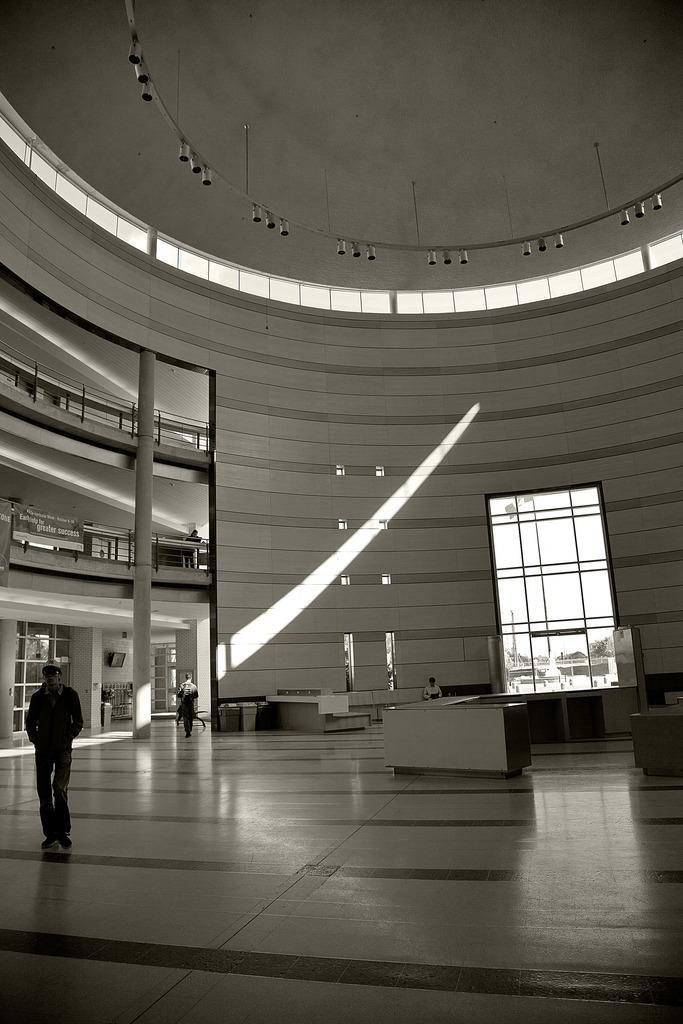Describe this image in one or two sentences. In this picture I can see there is a man walking on to left and there is another person walking in the backdrop, on to right there is a person sitting in the chair, there are few tables here on to right and there is a glass window and there are many other glass windows on the roof. There are few lights attached to the ceiling and there are railings on to left side. 